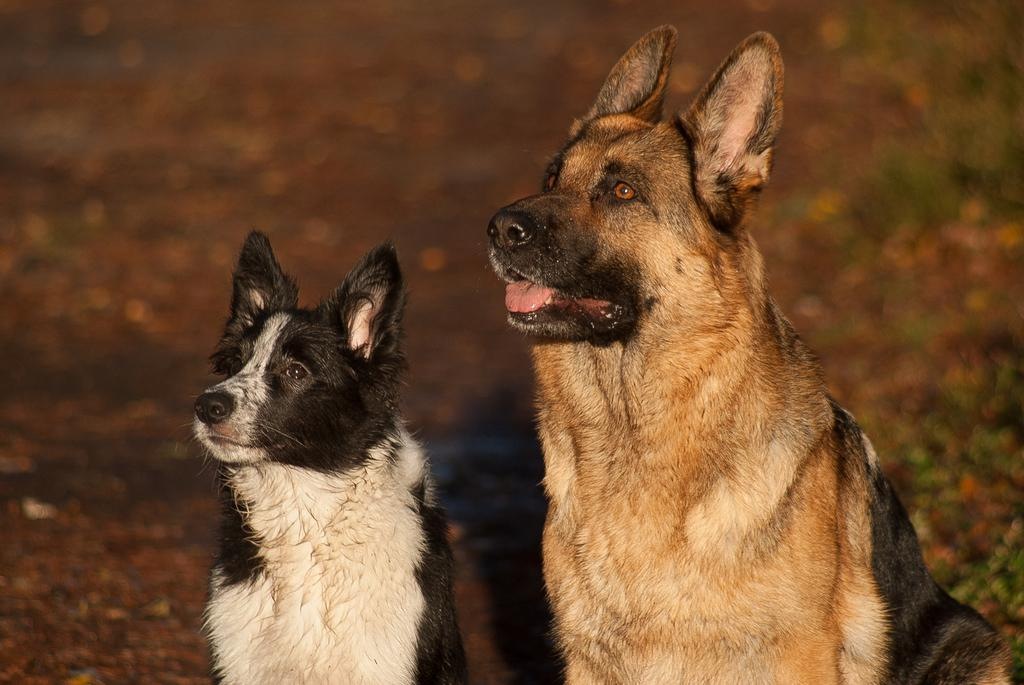What type of animals are present in the image? There are dogs in the image. How many geese are flying in a curve in the image? There are no geese or curves present in the image; it features dogs. 